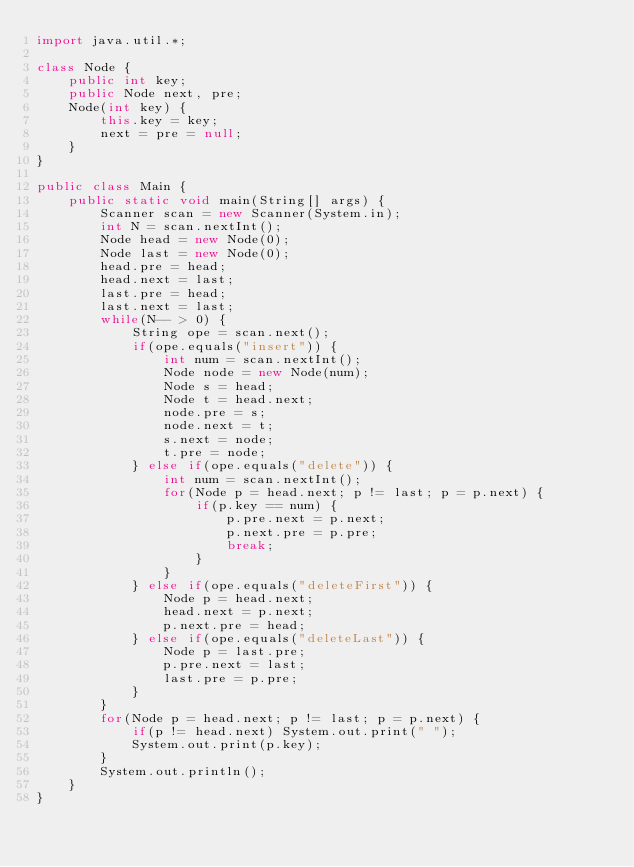Convert code to text. <code><loc_0><loc_0><loc_500><loc_500><_Java_>import java.util.*;

class Node {
    public int key;
    public Node next, pre;
    Node(int key) {
        this.key = key;
        next = pre = null;
    }
}

public class Main {
    public static void main(String[] args) {
        Scanner scan = new Scanner(System.in);
        int N = scan.nextInt();
        Node head = new Node(0);
        Node last = new Node(0);
        head.pre = head;
        head.next = last;
        last.pre = head;
        last.next = last;
        while(N-- > 0) {
            String ope = scan.next();
            if(ope.equals("insert")) {
                int num = scan.nextInt();
                Node node = new Node(num);
                Node s = head;
                Node t = head.next;
                node.pre = s;
                node.next = t;
                s.next = node;
                t.pre = node;
            } else if(ope.equals("delete")) {
                int num = scan.nextInt();
                for(Node p = head.next; p != last; p = p.next) {
                    if(p.key == num) {
                        p.pre.next = p.next;
                        p.next.pre = p.pre;
                        break;
                    }
                }
            } else if(ope.equals("deleteFirst")) {
                Node p = head.next;
                head.next = p.next;
                p.next.pre = head;
            } else if(ope.equals("deleteLast")) {
                Node p = last.pre;
                p.pre.next = last;
                last.pre = p.pre;
            }
        }
        for(Node p = head.next; p != last; p = p.next) {
            if(p != head.next) System.out.print(" ");
            System.out.print(p.key);
        }
        System.out.println();
    }
}</code> 